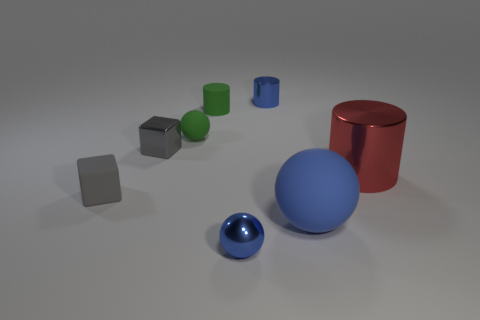The tiny blue metal thing that is behind the small green matte cylinder has what shape? The small object situated behind the green cylinder exhibits a spherical shape, with a smooth, reflective blue surface that indicates a metallic material. 